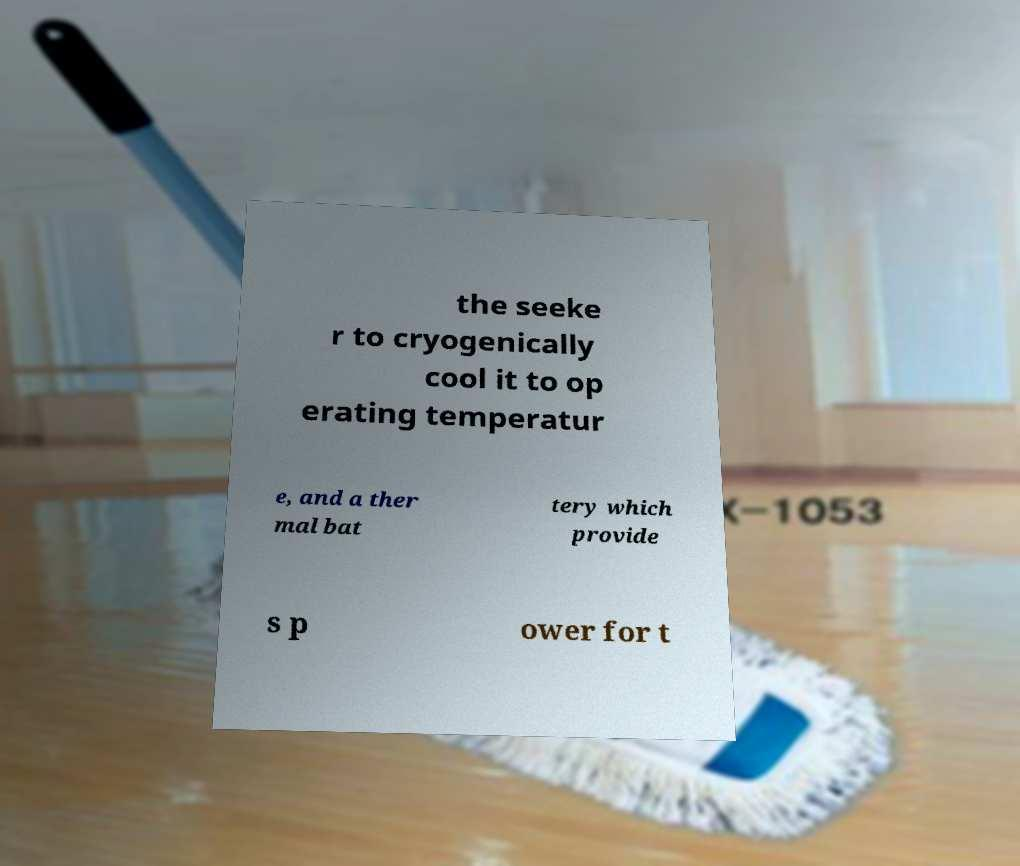Could you assist in decoding the text presented in this image and type it out clearly? the seeke r to cryogenically cool it to op erating temperatur e, and a ther mal bat tery which provide s p ower for t 